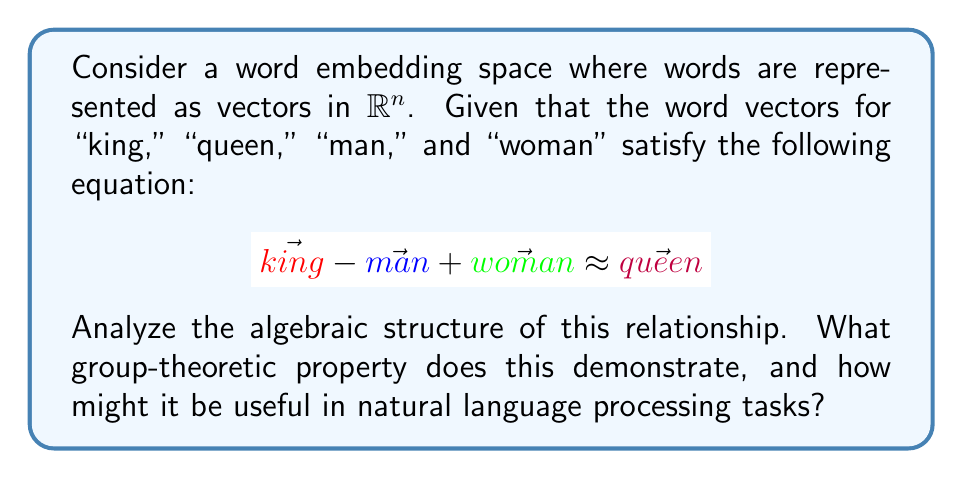Help me with this question. 1. Word embeddings represent words as vectors in a high-dimensional space, typically $\mathbb{R}^n$.

2. The given equation $\vec{king} - \vec{man} + \vec{woman} \approx \vec{queen}$ demonstrates vector addition and subtraction in this space.

3. This relationship exhibits the group-theoretic property of closure under addition and subtraction. The vector space forms an abelian group under these operations.

4. The operation can be interpreted as:
   $$\vec{king} - \vec{man} \approx \vec{queen} - \vec{woman}$$
   This shows that the difference between "king" and "man" is approximately equal to the difference between "queen" and "woman".

5. This property demonstrates the concept of analogy in the vector space. It captures semantic relationships between words.

6. In group theory, this is similar to the concept of cosets. If we consider the subspace generated by gender differences, we can view words related by gender as elements of the same coset.

7. This algebraic structure allows for meaningful vector arithmetic on word embeddings, enabling tasks such as:
   - Analogy solving: $\vec{king} - \vec{man} + \vec{woman} \approx \vec{queen}$
   - Semantic similarity measurement using vector distances
   - Identifying word relationships and categories

8. In NLP, this property is useful for:
   - Improving machine translation by capturing word relationships
   - Enhancing sentiment analysis by understanding word associations
   - Facilitating text generation tasks by providing meaningful word substitutions

This algebraic structure provides a powerful framework for representing and manipulating semantic relationships in NLP tasks.
Answer: Abelian group structure demonstrating closure and analogy, useful for semantic relationship modeling in NLP tasks. 